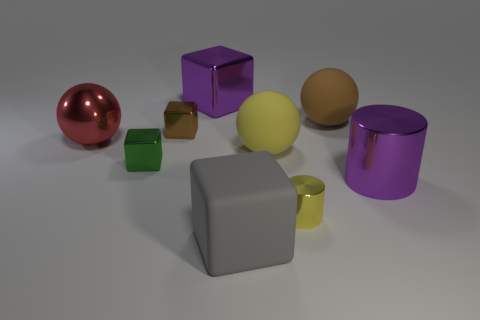Subtract all green shiny blocks. How many blocks are left? 3 Subtract all purple cubes. How many cubes are left? 3 Subtract all cubes. How many objects are left? 5 Subtract all green spheres. Subtract all blue cubes. How many spheres are left? 3 Add 4 brown blocks. How many brown blocks are left? 5 Add 8 small gray cubes. How many small gray cubes exist? 8 Subtract 0 cyan cubes. How many objects are left? 9 Subtract all large red cubes. Subtract all big metal spheres. How many objects are left? 8 